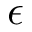<formula> <loc_0><loc_0><loc_500><loc_500>\epsilon</formula> 